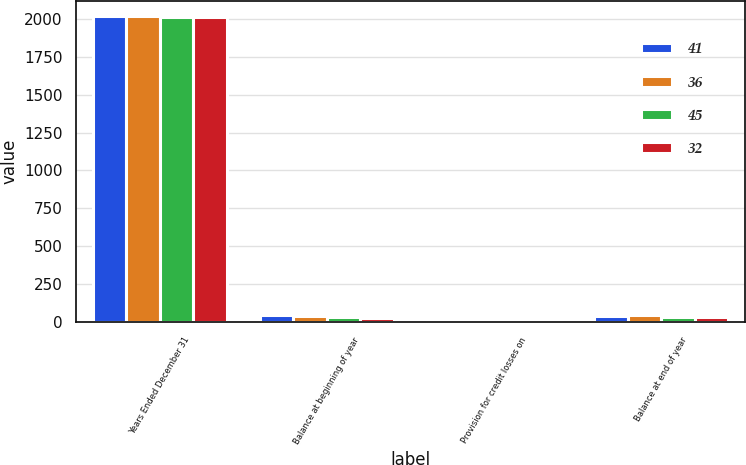Convert chart. <chart><loc_0><loc_0><loc_500><loc_500><stacked_bar_chart><ecel><fcel>Years Ended December 31<fcel>Balance at beginning of year<fcel>Provision for credit losses on<fcel>Balance at end of year<nl><fcel>41<fcel>2016<fcel>45<fcel>7<fcel>41<nl><fcel>36<fcel>2015<fcel>41<fcel>5<fcel>45<nl><fcel>45<fcel>2013<fcel>32<fcel>4<fcel>36<nl><fcel>32<fcel>2012<fcel>26<fcel>6<fcel>32<nl></chart> 